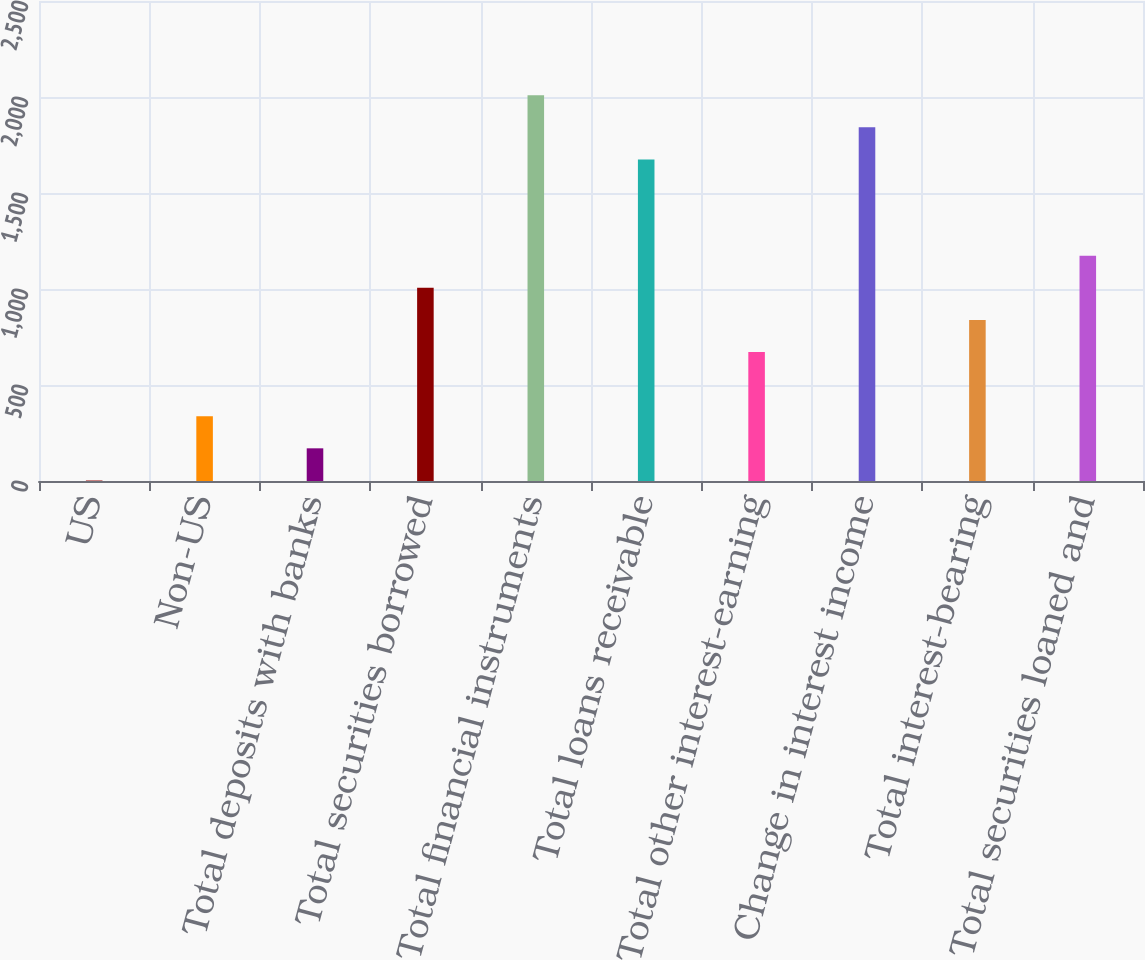Convert chart. <chart><loc_0><loc_0><loc_500><loc_500><bar_chart><fcel>US<fcel>Non-US<fcel>Total deposits with banks<fcel>Total securities borrowed<fcel>Total financial instruments<fcel>Total loans receivable<fcel>Total other interest-earning<fcel>Change in interest income<fcel>Total interest-bearing<fcel>Total securities loaned and<nl><fcel>3<fcel>337.4<fcel>170.2<fcel>1006.2<fcel>2009.4<fcel>1675<fcel>671.8<fcel>1842.2<fcel>839<fcel>1173.4<nl></chart> 